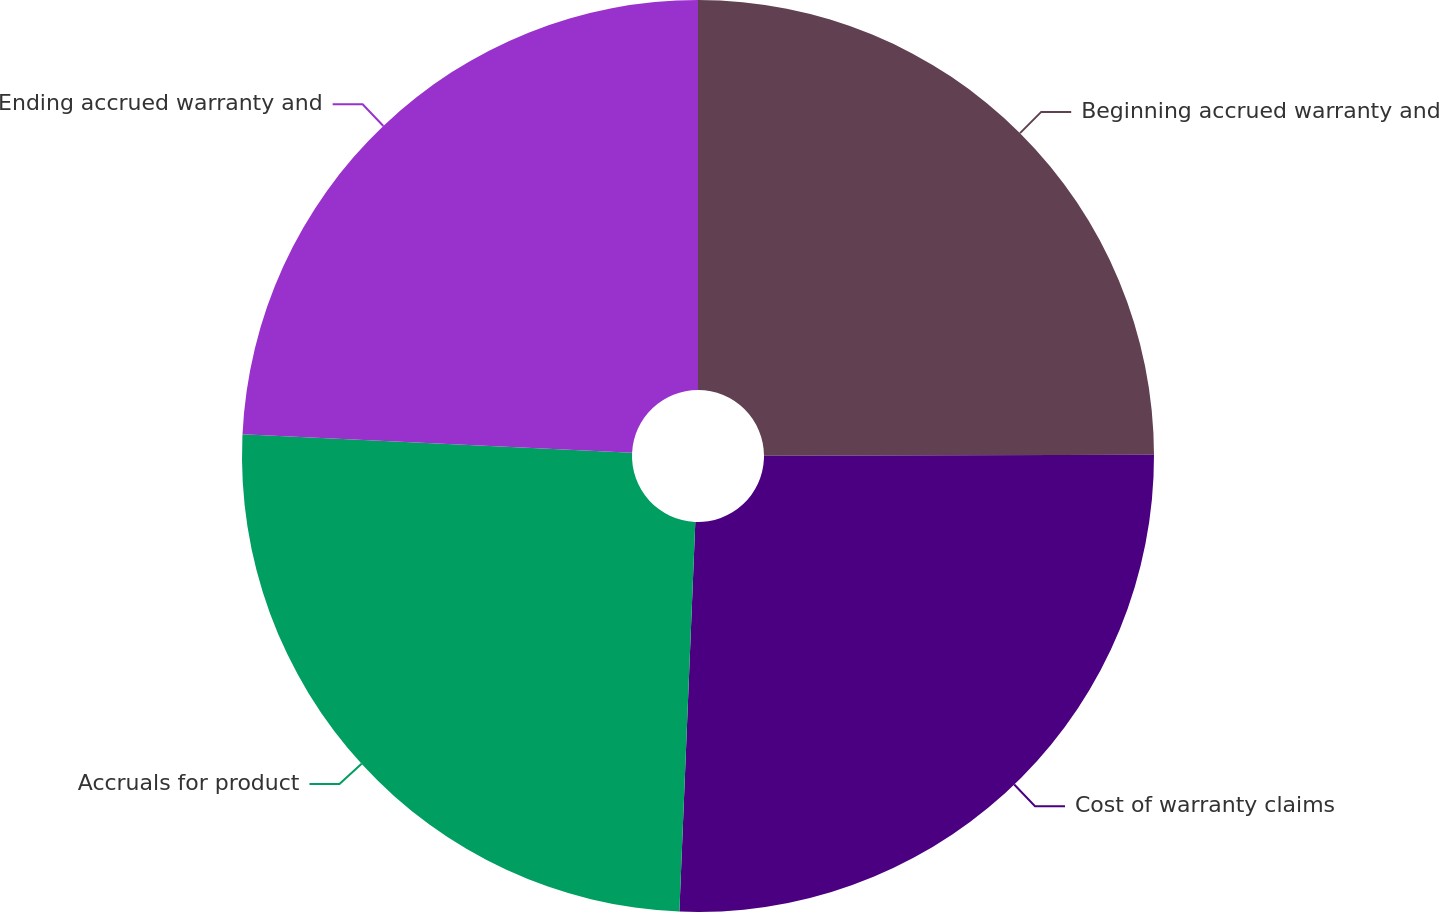Convert chart. <chart><loc_0><loc_0><loc_500><loc_500><pie_chart><fcel>Beginning accrued warranty and<fcel>Cost of warranty claims<fcel>Accruals for product<fcel>Ending accrued warranty and<nl><fcel>24.96%<fcel>25.69%<fcel>25.11%<fcel>24.24%<nl></chart> 